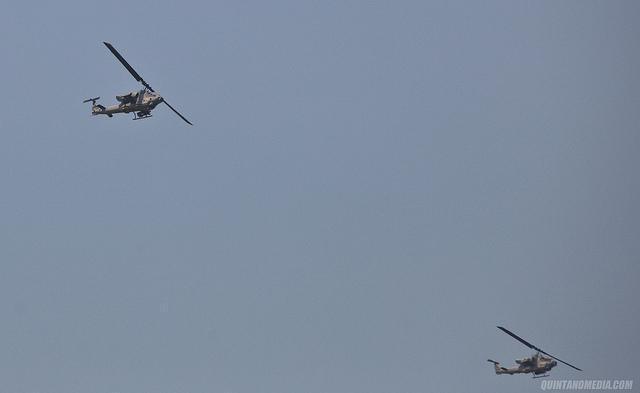How many vehicles are in this picture?
Give a very brief answer. 2. How many white computer mice are in the image?
Give a very brief answer. 0. 